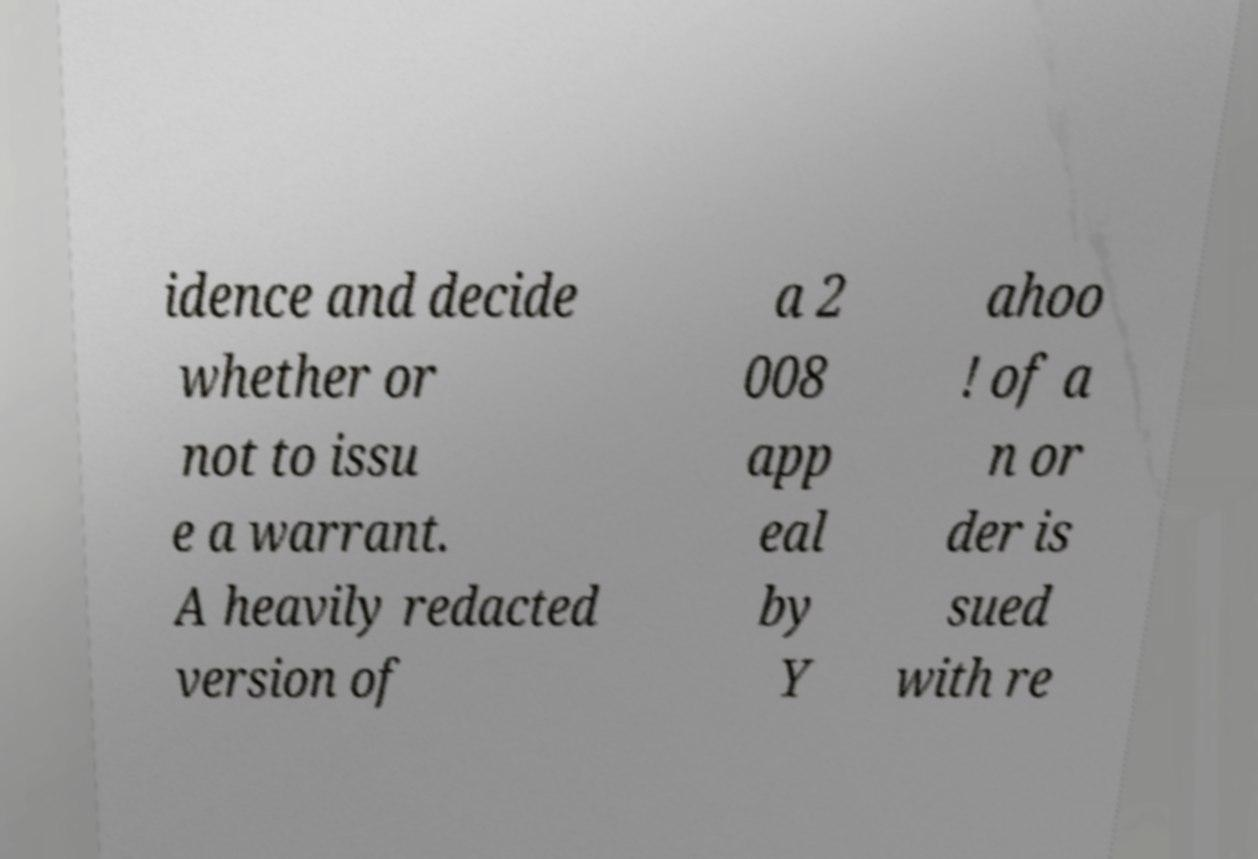I need the written content from this picture converted into text. Can you do that? idence and decide whether or not to issu e a warrant. A heavily redacted version of a 2 008 app eal by Y ahoo ! of a n or der is sued with re 